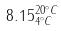<formula> <loc_0><loc_0><loc_500><loc_500>8 . 1 5 _ { 4 ^ { \circ } C } ^ { 2 0 ^ { \circ } C }</formula> 